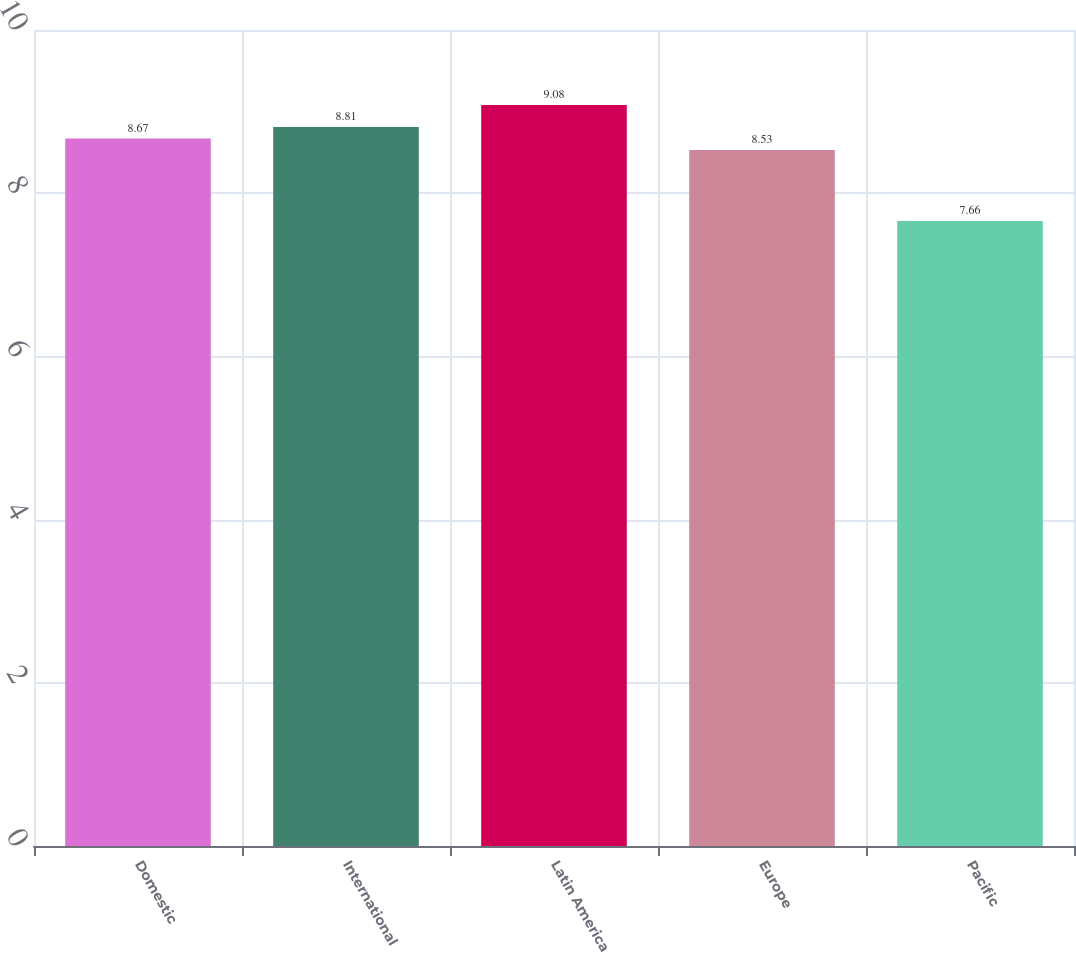Convert chart to OTSL. <chart><loc_0><loc_0><loc_500><loc_500><bar_chart><fcel>Domestic<fcel>International<fcel>Latin America<fcel>Europe<fcel>Pacific<nl><fcel>8.67<fcel>8.81<fcel>9.08<fcel>8.53<fcel>7.66<nl></chart> 